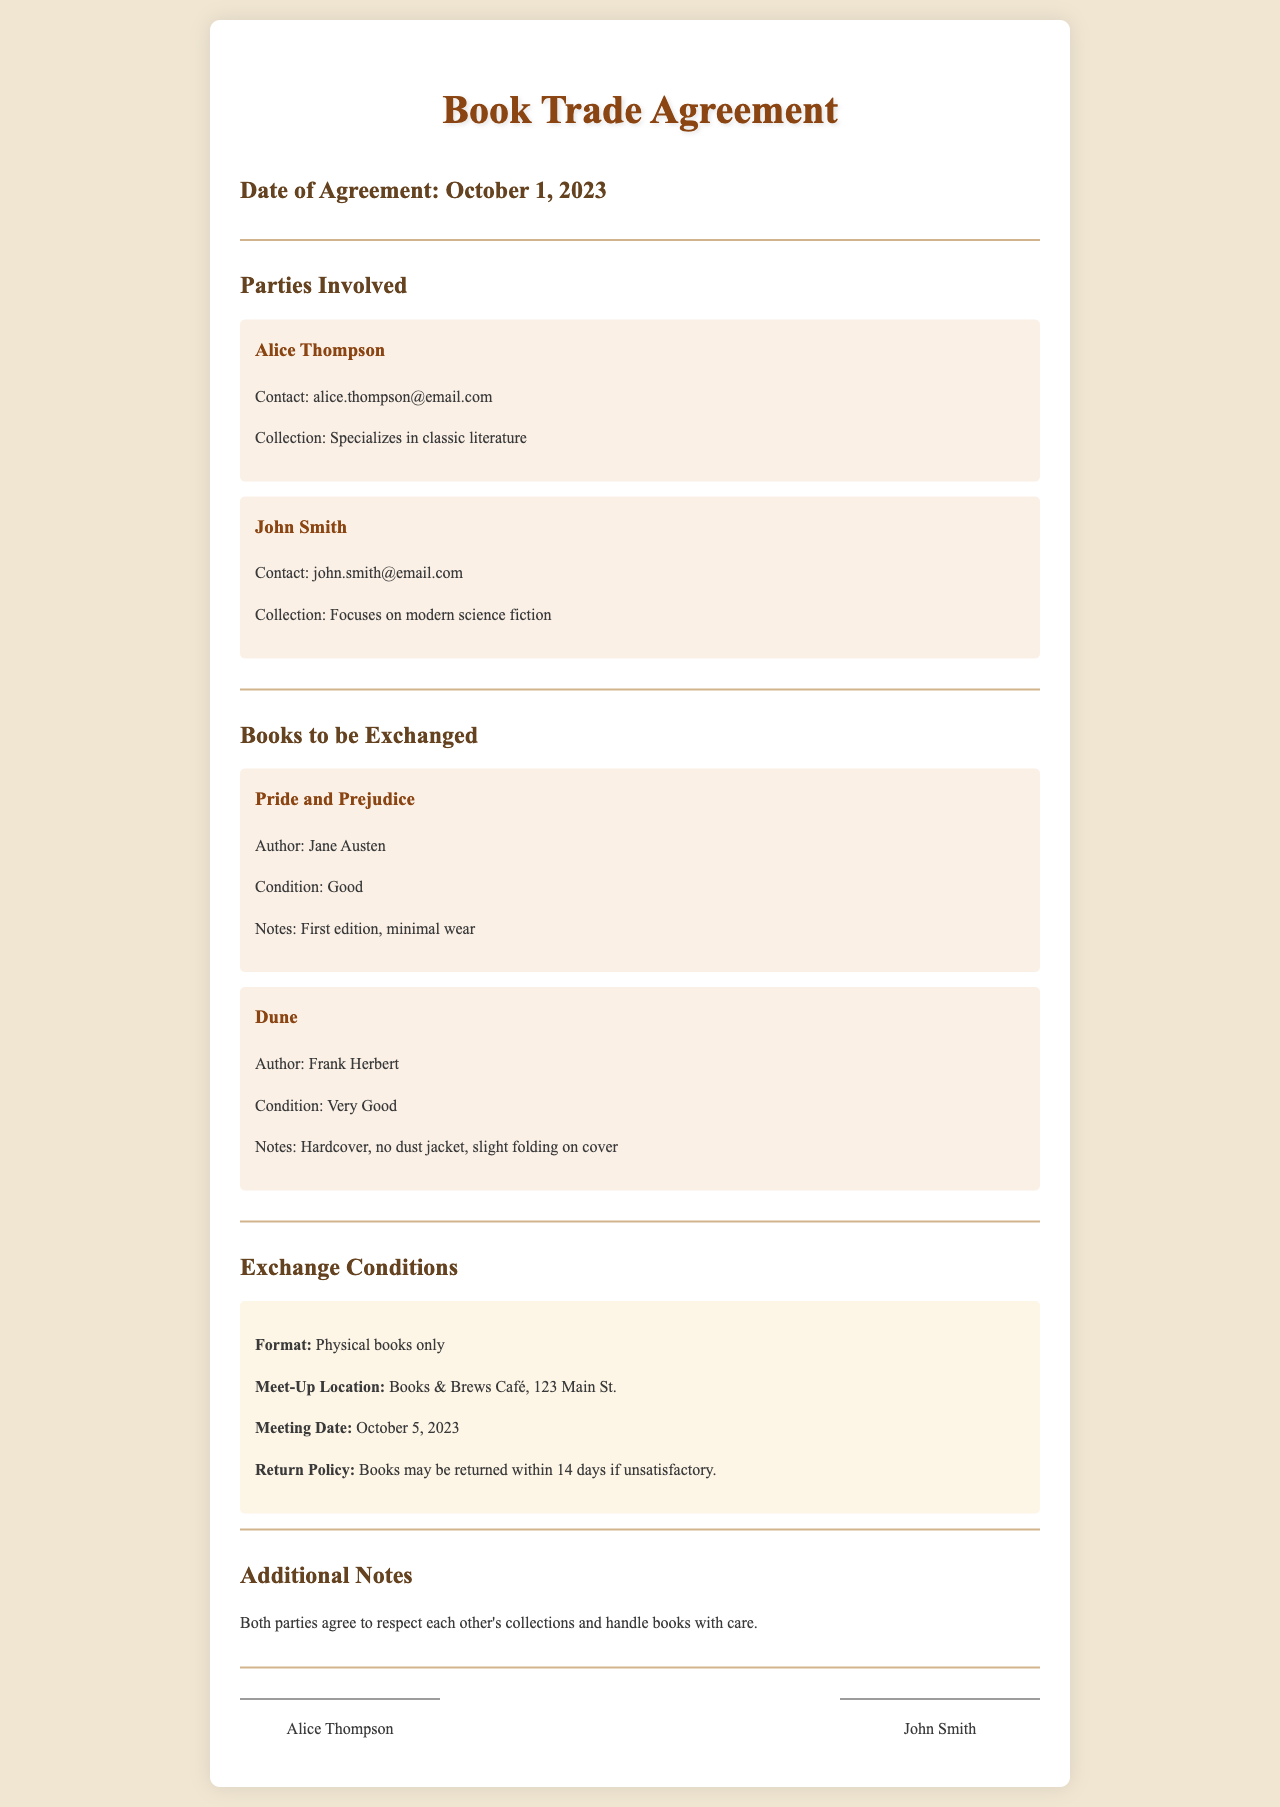What is the date of the agreement? The date of the agreement is stated in the document, mentioned explicitly as October 1, 2023.
Answer: October 1, 2023 Who is the first party involved? The first party mentioned in the document is Alice Thompson, who is listed at the beginning under Parties Involved.
Answer: Alice Thompson What is the title of the book being exchanged by Alice? The document specifies the book that Alice is exchanging, which is listed under Books to be Exchanged.
Answer: Pride and Prejudice What condition is the book "Dune" in? The condition of the book "Dune" is directly stated in the description of that book in the document.
Answer: Very Good What is the meeting date for the exchange? The meeting date is outlined in the Exchange Conditions section, indicating when the parties will meet for the trade.
Answer: October 5, 2023 How long do parties have to return books if unsatisfactory? The return policy states a specific duration for returns, which can be found in the Exchange Conditions section of the document.
Answer: 14 days What genre of books does John Smith focus on? John Smith's collection specialization is mentioned in the description of his party section.
Answer: Modern science fiction Where is the meet-up location for the book exchange? The document specifies the location for the exchange meeting under the Exchange Conditions, mentioning a specific venue.
Answer: Books & Brews Café, 123 Main St What is included in the additional notes? The additional notes section provides a general sense of conduct expected from both parties during the exchange.
Answer: Respect each other's collections and handle books with care 